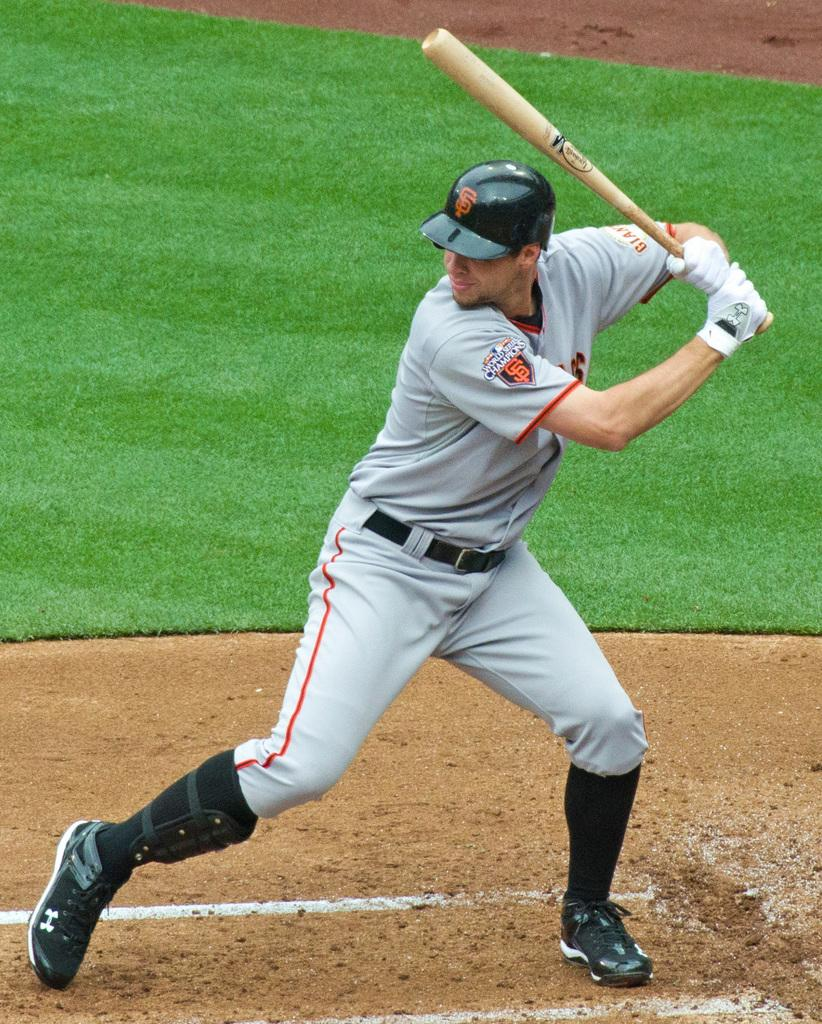Who is present in the image? There is a man in the image. What is the man holding in his hands? The man is holding a bat in his hands. Can you describe the location of the image? The location is described as ground. What type of produce is the man holding in the image? The man is not holding any produce in the image; he is holding a bat. Can you tell me the statement the man is making in the image? There is no statement being made by the man in the image. 